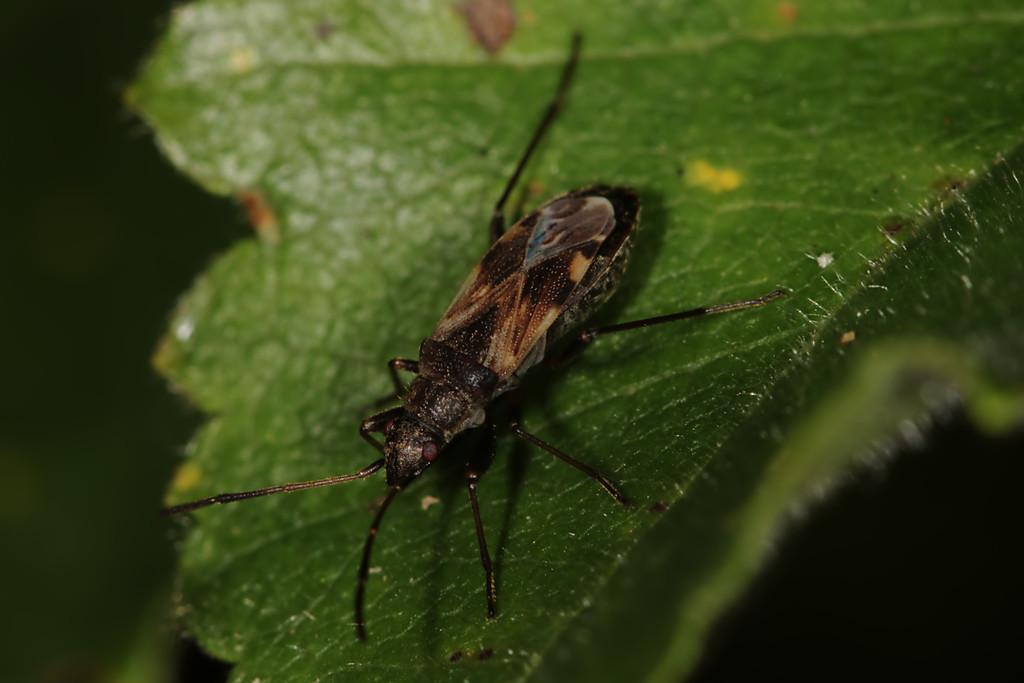What is present on the green leaf in the image? There is an insect on the green leaf in the image. Can you describe the insect's location in the image? The insect is on a green leaf in the image. What type of appliance is visible in the image? There is no appliance present in the image; it features an insect on a green leaf. Is there a ghost visible in the image? There is no ghost present in the image; it features an insect on a green leaf. 